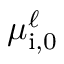<formula> <loc_0><loc_0><loc_500><loc_500>\mu _ { i , 0 } ^ { \ell }</formula> 